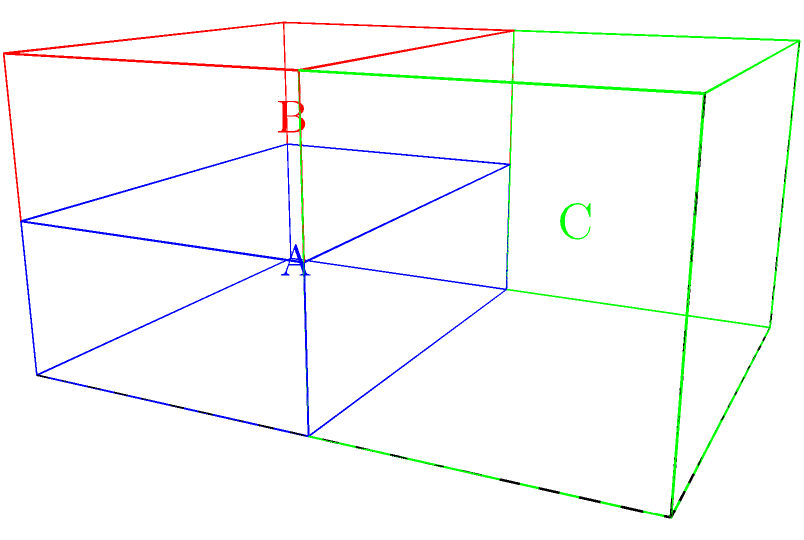You have three types of sneaker boxes with different dimensions:
Box A: 3 x 2 x 1 units
Box B: 3 x 2 x 1 units
Box C: 3 x 2 x 2 units

Given a storage space of 3 x 4 x 2 units, what is the maximum number of sneaker boxes that can be stored, and what is the optimal arrangement to maximize space utilization? To solve this problem, we need to consider the dimensions of the storage space and the individual box types:

Storage space: 3 x 4 x 2 units
Box A: 3 x 2 x 1 units
Box B: 3 x 2 x 1 units
Box C: 3 x 2 x 2 units

Step 1: Analyze the storage space
The storage space can be divided into two layers of 3 x 4 x 1 units each.

Step 2: Consider Box C
Box C has a height of 2 units, which is equal to the height of the storage space. We can fit one Box C in the storage space, occupying 3 x 2 x 2 units.

Step 3: Fill the remaining space with Box A and Box B
After placing Box C, we have a remaining space of 3 x 2 x 2 units, which can be filled with four boxes of type A or B (two in each layer).

Step 4: Calculate the total number of boxes
1 Box C + 4 Box A/B = 5 boxes total

Step 5: Verify the arrangement
The optimal arrangement is:
- Bottom layer: 1 Box C (3 x 2 x 2) + 1 Box A/B (3 x 2 x 1)
- Top layer: 2 Box A/B (3 x 2 x 1 each)

This arrangement fully utilizes the available space of 3 x 4 x 2 units.

Step 6: Check for alternative arrangements
No other arrangement can fit more than 5 boxes while fully utilizing the space.

Therefore, the maximum number of sneaker boxes that can be stored is 5, with the optimal arrangement being 1 Box C and 4 Boxes of type A or B.
Answer: 5 boxes (1 Box C, 4 Box A/B) 